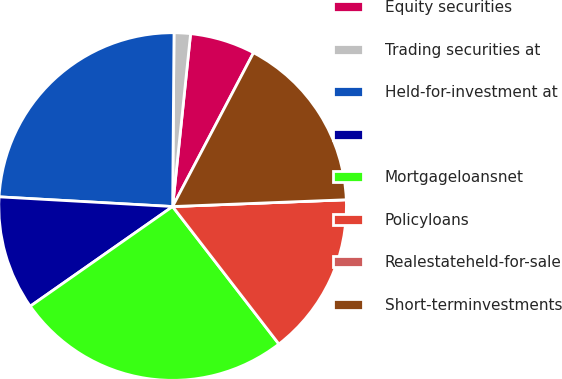Convert chart to OTSL. <chart><loc_0><loc_0><loc_500><loc_500><pie_chart><fcel>Equity securities<fcel>Trading securities at<fcel>Held-for-investment at<fcel>Unnamed: 3<fcel>Mortgageloansnet<fcel>Policyloans<fcel>Realestateheld-for-sale<fcel>Short-terminvestments<nl><fcel>6.06%<fcel>1.52%<fcel>24.24%<fcel>10.61%<fcel>25.75%<fcel>15.15%<fcel>0.0%<fcel>16.67%<nl></chart> 